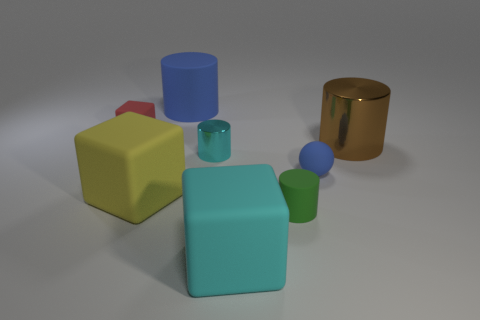What is the size of the blue rubber cylinder?
Give a very brief answer. Large. There is a green object that is the same material as the blue ball; what shape is it?
Offer a very short reply. Cylinder. Does the blue object to the right of the tiny shiny object have the same shape as the big yellow matte object?
Give a very brief answer. No. How many objects are matte balls or large cyan matte things?
Provide a short and direct response. 2. What is the material of the small thing that is on the right side of the cyan matte thing and behind the green thing?
Offer a terse response. Rubber. Is the size of the cyan cylinder the same as the blue ball?
Provide a succinct answer. Yes. What is the size of the cyan matte thing in front of the blue thing that is behind the tiny red cube?
Make the answer very short. Large. What number of objects are both behind the red rubber cube and left of the blue matte cylinder?
Keep it short and to the point. 0. Are there any large cyan things that are behind the rubber block that is on the right side of the large thing that is behind the small red cube?
Keep it short and to the point. No. There is a metallic object that is the same size as the red rubber object; what shape is it?
Your answer should be compact. Cylinder. 